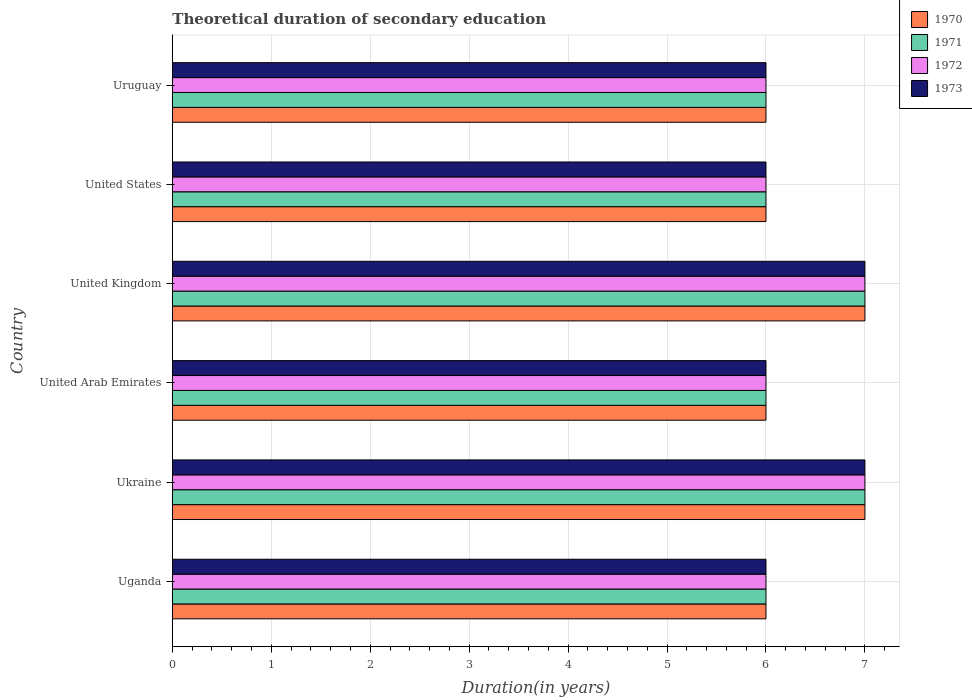Are the number of bars on each tick of the Y-axis equal?
Make the answer very short. Yes. How many bars are there on the 2nd tick from the top?
Ensure brevity in your answer.  4. What is the label of the 2nd group of bars from the top?
Provide a succinct answer. United States. Across all countries, what is the maximum total theoretical duration of secondary education in 1972?
Offer a terse response. 7. In which country was the total theoretical duration of secondary education in 1972 maximum?
Provide a succinct answer. Ukraine. In which country was the total theoretical duration of secondary education in 1973 minimum?
Your answer should be compact. Uganda. What is the total total theoretical duration of secondary education in 1972 in the graph?
Keep it short and to the point. 38. What is the average total theoretical duration of secondary education in 1973 per country?
Provide a short and direct response. 6.33. In how many countries, is the total theoretical duration of secondary education in 1971 greater than 5 years?
Give a very brief answer. 6. What is the difference between the highest and the lowest total theoretical duration of secondary education in 1972?
Your answer should be compact. 1. Is it the case that in every country, the sum of the total theoretical duration of secondary education in 1973 and total theoretical duration of secondary education in 1971 is greater than the sum of total theoretical duration of secondary education in 1970 and total theoretical duration of secondary education in 1972?
Offer a terse response. No. Is it the case that in every country, the sum of the total theoretical duration of secondary education in 1973 and total theoretical duration of secondary education in 1970 is greater than the total theoretical duration of secondary education in 1972?
Provide a succinct answer. Yes. How many bars are there?
Your answer should be compact. 24. How many countries are there in the graph?
Provide a short and direct response. 6. Are the values on the major ticks of X-axis written in scientific E-notation?
Provide a succinct answer. No. Does the graph contain any zero values?
Your response must be concise. No. Does the graph contain grids?
Give a very brief answer. Yes. How are the legend labels stacked?
Offer a terse response. Vertical. What is the title of the graph?
Offer a very short reply. Theoretical duration of secondary education. What is the label or title of the X-axis?
Provide a short and direct response. Duration(in years). What is the Duration(in years) in 1972 in Uganda?
Your answer should be compact. 6. What is the Duration(in years) in 1973 in Uganda?
Your response must be concise. 6. What is the Duration(in years) of 1970 in Ukraine?
Your answer should be compact. 7. What is the Duration(in years) of 1973 in Ukraine?
Give a very brief answer. 7. What is the Duration(in years) in 1970 in United Arab Emirates?
Your response must be concise. 6. What is the Duration(in years) of 1972 in United Arab Emirates?
Give a very brief answer. 6. What is the Duration(in years) of 1973 in United Arab Emirates?
Your answer should be very brief. 6. What is the Duration(in years) of 1970 in United Kingdom?
Provide a short and direct response. 7. What is the Duration(in years) in 1971 in United Kingdom?
Keep it short and to the point. 7. What is the Duration(in years) of 1972 in United Kingdom?
Ensure brevity in your answer.  7. What is the Duration(in years) of 1973 in United Kingdom?
Provide a succinct answer. 7. What is the Duration(in years) of 1972 in United States?
Give a very brief answer. 6. What is the Duration(in years) of 1973 in United States?
Your response must be concise. 6. What is the Duration(in years) in 1971 in Uruguay?
Give a very brief answer. 6. Across all countries, what is the minimum Duration(in years) of 1971?
Keep it short and to the point. 6. What is the total Duration(in years) of 1971 in the graph?
Give a very brief answer. 38. What is the total Duration(in years) in 1972 in the graph?
Your answer should be very brief. 38. What is the difference between the Duration(in years) in 1970 in Uganda and that in Ukraine?
Your answer should be very brief. -1. What is the difference between the Duration(in years) of 1971 in Uganda and that in Ukraine?
Offer a very short reply. -1. What is the difference between the Duration(in years) in 1973 in Uganda and that in Ukraine?
Your answer should be compact. -1. What is the difference between the Duration(in years) in 1970 in Uganda and that in United Arab Emirates?
Ensure brevity in your answer.  0. What is the difference between the Duration(in years) of 1971 in Uganda and that in United Arab Emirates?
Give a very brief answer. 0. What is the difference between the Duration(in years) of 1972 in Uganda and that in United Arab Emirates?
Provide a short and direct response. 0. What is the difference between the Duration(in years) of 1973 in Uganda and that in United Arab Emirates?
Keep it short and to the point. 0. What is the difference between the Duration(in years) in 1970 in Uganda and that in United Kingdom?
Ensure brevity in your answer.  -1. What is the difference between the Duration(in years) of 1971 in Uganda and that in United Kingdom?
Offer a very short reply. -1. What is the difference between the Duration(in years) in 1972 in Uganda and that in United Kingdom?
Keep it short and to the point. -1. What is the difference between the Duration(in years) of 1973 in Uganda and that in United Kingdom?
Provide a succinct answer. -1. What is the difference between the Duration(in years) of 1970 in Uganda and that in Uruguay?
Make the answer very short. 0. What is the difference between the Duration(in years) of 1972 in Ukraine and that in United Arab Emirates?
Give a very brief answer. 1. What is the difference between the Duration(in years) of 1973 in Ukraine and that in United Arab Emirates?
Give a very brief answer. 1. What is the difference between the Duration(in years) of 1971 in Ukraine and that in United Kingdom?
Make the answer very short. 0. What is the difference between the Duration(in years) in 1972 in Ukraine and that in United Kingdom?
Your answer should be very brief. 0. What is the difference between the Duration(in years) of 1973 in Ukraine and that in United Kingdom?
Make the answer very short. 0. What is the difference between the Duration(in years) of 1970 in Ukraine and that in Uruguay?
Keep it short and to the point. 1. What is the difference between the Duration(in years) in 1971 in Ukraine and that in Uruguay?
Ensure brevity in your answer.  1. What is the difference between the Duration(in years) of 1972 in Ukraine and that in Uruguay?
Your answer should be compact. 1. What is the difference between the Duration(in years) in 1973 in Ukraine and that in Uruguay?
Give a very brief answer. 1. What is the difference between the Duration(in years) of 1971 in United Arab Emirates and that in United Kingdom?
Your answer should be very brief. -1. What is the difference between the Duration(in years) of 1972 in United Arab Emirates and that in United Kingdom?
Ensure brevity in your answer.  -1. What is the difference between the Duration(in years) of 1970 in United Arab Emirates and that in United States?
Give a very brief answer. 0. What is the difference between the Duration(in years) in 1971 in United Arab Emirates and that in United States?
Provide a succinct answer. 0. What is the difference between the Duration(in years) of 1972 in United Arab Emirates and that in United States?
Offer a terse response. 0. What is the difference between the Duration(in years) in 1973 in United Arab Emirates and that in United States?
Ensure brevity in your answer.  0. What is the difference between the Duration(in years) in 1970 in United Arab Emirates and that in Uruguay?
Make the answer very short. 0. What is the difference between the Duration(in years) of 1971 in United Arab Emirates and that in Uruguay?
Offer a very short reply. 0. What is the difference between the Duration(in years) of 1973 in United Arab Emirates and that in Uruguay?
Offer a very short reply. 0. What is the difference between the Duration(in years) of 1971 in United Kingdom and that in United States?
Keep it short and to the point. 1. What is the difference between the Duration(in years) in 1971 in United Kingdom and that in Uruguay?
Your response must be concise. 1. What is the difference between the Duration(in years) of 1972 in United Kingdom and that in Uruguay?
Provide a short and direct response. 1. What is the difference between the Duration(in years) in 1971 in United States and that in Uruguay?
Make the answer very short. 0. What is the difference between the Duration(in years) in 1972 in United States and that in Uruguay?
Give a very brief answer. 0. What is the difference between the Duration(in years) in 1970 in Uganda and the Duration(in years) in 1971 in Ukraine?
Your response must be concise. -1. What is the difference between the Duration(in years) of 1971 in Uganda and the Duration(in years) of 1973 in Ukraine?
Ensure brevity in your answer.  -1. What is the difference between the Duration(in years) in 1970 in Uganda and the Duration(in years) in 1971 in United Arab Emirates?
Offer a very short reply. 0. What is the difference between the Duration(in years) in 1971 in Uganda and the Duration(in years) in 1972 in United Arab Emirates?
Make the answer very short. 0. What is the difference between the Duration(in years) of 1971 in Uganda and the Duration(in years) of 1973 in United Arab Emirates?
Your answer should be very brief. 0. What is the difference between the Duration(in years) of 1970 in Uganda and the Duration(in years) of 1972 in United Kingdom?
Provide a short and direct response. -1. What is the difference between the Duration(in years) in 1971 in Uganda and the Duration(in years) in 1973 in United Kingdom?
Offer a terse response. -1. What is the difference between the Duration(in years) of 1972 in Uganda and the Duration(in years) of 1973 in United Kingdom?
Offer a very short reply. -1. What is the difference between the Duration(in years) in 1970 in Uganda and the Duration(in years) in 1971 in United States?
Provide a short and direct response. 0. What is the difference between the Duration(in years) of 1970 in Uganda and the Duration(in years) of 1973 in United States?
Give a very brief answer. 0. What is the difference between the Duration(in years) of 1972 in Uganda and the Duration(in years) of 1973 in United States?
Keep it short and to the point. 0. What is the difference between the Duration(in years) of 1970 in Uganda and the Duration(in years) of 1973 in Uruguay?
Your answer should be very brief. 0. What is the difference between the Duration(in years) of 1971 in Uganda and the Duration(in years) of 1973 in Uruguay?
Give a very brief answer. 0. What is the difference between the Duration(in years) of 1972 in Uganda and the Duration(in years) of 1973 in Uruguay?
Offer a very short reply. 0. What is the difference between the Duration(in years) in 1972 in Ukraine and the Duration(in years) in 1973 in United Arab Emirates?
Keep it short and to the point. 1. What is the difference between the Duration(in years) in 1970 in Ukraine and the Duration(in years) in 1973 in United Kingdom?
Offer a very short reply. 0. What is the difference between the Duration(in years) in 1971 in Ukraine and the Duration(in years) in 1973 in United Kingdom?
Provide a short and direct response. 0. What is the difference between the Duration(in years) of 1971 in Ukraine and the Duration(in years) of 1972 in United States?
Your answer should be compact. 1. What is the difference between the Duration(in years) in 1970 in Ukraine and the Duration(in years) in 1971 in Uruguay?
Make the answer very short. 1. What is the difference between the Duration(in years) in 1970 in Ukraine and the Duration(in years) in 1972 in Uruguay?
Offer a terse response. 1. What is the difference between the Duration(in years) in 1970 in Ukraine and the Duration(in years) in 1973 in Uruguay?
Offer a terse response. 1. What is the difference between the Duration(in years) in 1971 in Ukraine and the Duration(in years) in 1973 in Uruguay?
Your answer should be compact. 1. What is the difference between the Duration(in years) of 1972 in Ukraine and the Duration(in years) of 1973 in Uruguay?
Offer a very short reply. 1. What is the difference between the Duration(in years) of 1971 in United Arab Emirates and the Duration(in years) of 1973 in United Kingdom?
Make the answer very short. -1. What is the difference between the Duration(in years) of 1972 in United Arab Emirates and the Duration(in years) of 1973 in United Kingdom?
Provide a succinct answer. -1. What is the difference between the Duration(in years) in 1970 in United Arab Emirates and the Duration(in years) in 1971 in United States?
Give a very brief answer. 0. What is the difference between the Duration(in years) in 1970 in United Arab Emirates and the Duration(in years) in 1972 in United States?
Keep it short and to the point. 0. What is the difference between the Duration(in years) in 1971 in United Arab Emirates and the Duration(in years) in 1973 in United States?
Provide a short and direct response. 0. What is the difference between the Duration(in years) in 1970 in United Arab Emirates and the Duration(in years) in 1971 in Uruguay?
Make the answer very short. 0. What is the difference between the Duration(in years) in 1970 in United Arab Emirates and the Duration(in years) in 1973 in Uruguay?
Your answer should be very brief. 0. What is the difference between the Duration(in years) of 1970 in United Kingdom and the Duration(in years) of 1971 in United States?
Your answer should be compact. 1. What is the difference between the Duration(in years) of 1970 in United Kingdom and the Duration(in years) of 1972 in United States?
Give a very brief answer. 1. What is the difference between the Duration(in years) of 1971 in United Kingdom and the Duration(in years) of 1972 in United States?
Provide a succinct answer. 1. What is the difference between the Duration(in years) of 1972 in United Kingdom and the Duration(in years) of 1973 in United States?
Make the answer very short. 1. What is the difference between the Duration(in years) in 1970 in United Kingdom and the Duration(in years) in 1972 in Uruguay?
Provide a short and direct response. 1. What is the difference between the Duration(in years) in 1970 in United Kingdom and the Duration(in years) in 1973 in Uruguay?
Make the answer very short. 1. What is the difference between the Duration(in years) of 1972 in United Kingdom and the Duration(in years) of 1973 in Uruguay?
Make the answer very short. 1. What is the difference between the Duration(in years) in 1970 in United States and the Duration(in years) in 1971 in Uruguay?
Your response must be concise. 0. What is the difference between the Duration(in years) in 1970 in United States and the Duration(in years) in 1972 in Uruguay?
Your answer should be compact. 0. What is the difference between the Duration(in years) of 1970 in United States and the Duration(in years) of 1973 in Uruguay?
Your response must be concise. 0. What is the average Duration(in years) of 1970 per country?
Your answer should be compact. 6.33. What is the average Duration(in years) in 1971 per country?
Ensure brevity in your answer.  6.33. What is the average Duration(in years) in 1972 per country?
Your answer should be compact. 6.33. What is the average Duration(in years) in 1973 per country?
Give a very brief answer. 6.33. What is the difference between the Duration(in years) in 1971 and Duration(in years) in 1973 in Uganda?
Provide a short and direct response. 0. What is the difference between the Duration(in years) in 1972 and Duration(in years) in 1973 in Uganda?
Make the answer very short. 0. What is the difference between the Duration(in years) in 1970 and Duration(in years) in 1971 in Ukraine?
Give a very brief answer. 0. What is the difference between the Duration(in years) in 1970 and Duration(in years) in 1972 in Ukraine?
Your response must be concise. 0. What is the difference between the Duration(in years) in 1970 and Duration(in years) in 1972 in United Arab Emirates?
Provide a short and direct response. 0. What is the difference between the Duration(in years) in 1970 and Duration(in years) in 1973 in United Arab Emirates?
Your answer should be compact. 0. What is the difference between the Duration(in years) in 1970 and Duration(in years) in 1971 in United Kingdom?
Give a very brief answer. 0. What is the difference between the Duration(in years) of 1970 and Duration(in years) of 1972 in United Kingdom?
Make the answer very short. 0. What is the difference between the Duration(in years) in 1970 and Duration(in years) in 1973 in United Kingdom?
Ensure brevity in your answer.  0. What is the difference between the Duration(in years) of 1971 and Duration(in years) of 1972 in United Kingdom?
Ensure brevity in your answer.  0. What is the difference between the Duration(in years) of 1971 and Duration(in years) of 1973 in United Kingdom?
Your answer should be compact. 0. What is the difference between the Duration(in years) of 1970 and Duration(in years) of 1971 in United States?
Offer a terse response. 0. What is the difference between the Duration(in years) in 1970 and Duration(in years) in 1972 in United States?
Give a very brief answer. 0. What is the difference between the Duration(in years) of 1970 and Duration(in years) of 1973 in United States?
Offer a very short reply. 0. What is the difference between the Duration(in years) in 1971 and Duration(in years) in 1972 in United States?
Provide a short and direct response. 0. What is the difference between the Duration(in years) in 1972 and Duration(in years) in 1973 in United States?
Offer a terse response. 0. What is the difference between the Duration(in years) in 1970 and Duration(in years) in 1973 in Uruguay?
Your answer should be compact. 0. What is the difference between the Duration(in years) of 1971 and Duration(in years) of 1972 in Uruguay?
Offer a terse response. 0. What is the difference between the Duration(in years) in 1972 and Duration(in years) in 1973 in Uruguay?
Your answer should be very brief. 0. What is the ratio of the Duration(in years) of 1970 in Uganda to that in Ukraine?
Provide a succinct answer. 0.86. What is the ratio of the Duration(in years) of 1971 in Uganda to that in Ukraine?
Ensure brevity in your answer.  0.86. What is the ratio of the Duration(in years) of 1970 in Uganda to that in United Arab Emirates?
Provide a short and direct response. 1. What is the ratio of the Duration(in years) in 1973 in Uganda to that in United Arab Emirates?
Your answer should be very brief. 1. What is the ratio of the Duration(in years) in 1970 in Uganda to that in United Kingdom?
Offer a very short reply. 0.86. What is the ratio of the Duration(in years) in 1971 in Uganda to that in United Kingdom?
Your answer should be compact. 0.86. What is the ratio of the Duration(in years) of 1972 in Uganda to that in United Kingdom?
Your response must be concise. 0.86. What is the ratio of the Duration(in years) in 1970 in Uganda to that in United States?
Offer a terse response. 1. What is the ratio of the Duration(in years) in 1971 in Uganda to that in United States?
Your answer should be compact. 1. What is the ratio of the Duration(in years) of 1972 in Uganda to that in United States?
Provide a short and direct response. 1. What is the ratio of the Duration(in years) in 1973 in Uganda to that in United States?
Ensure brevity in your answer.  1. What is the ratio of the Duration(in years) of 1971 in Uganda to that in Uruguay?
Your response must be concise. 1. What is the ratio of the Duration(in years) in 1973 in Uganda to that in Uruguay?
Your response must be concise. 1. What is the ratio of the Duration(in years) of 1970 in Ukraine to that in United Arab Emirates?
Provide a succinct answer. 1.17. What is the ratio of the Duration(in years) of 1971 in Ukraine to that in United Arab Emirates?
Your answer should be very brief. 1.17. What is the ratio of the Duration(in years) of 1972 in Ukraine to that in United Arab Emirates?
Provide a succinct answer. 1.17. What is the ratio of the Duration(in years) of 1973 in Ukraine to that in United Arab Emirates?
Ensure brevity in your answer.  1.17. What is the ratio of the Duration(in years) of 1971 in Ukraine to that in United Kingdom?
Provide a succinct answer. 1. What is the ratio of the Duration(in years) of 1973 in Ukraine to that in United Kingdom?
Provide a succinct answer. 1. What is the ratio of the Duration(in years) in 1970 in Ukraine to that in United States?
Your response must be concise. 1.17. What is the ratio of the Duration(in years) of 1973 in Ukraine to that in United States?
Ensure brevity in your answer.  1.17. What is the ratio of the Duration(in years) in 1971 in Ukraine to that in Uruguay?
Make the answer very short. 1.17. What is the ratio of the Duration(in years) in 1973 in Ukraine to that in Uruguay?
Keep it short and to the point. 1.17. What is the ratio of the Duration(in years) of 1970 in United Arab Emirates to that in United Kingdom?
Offer a terse response. 0.86. What is the ratio of the Duration(in years) of 1970 in United Arab Emirates to that in United States?
Offer a very short reply. 1. What is the ratio of the Duration(in years) in 1972 in United Arab Emirates to that in Uruguay?
Give a very brief answer. 1. What is the ratio of the Duration(in years) in 1973 in United Arab Emirates to that in Uruguay?
Your answer should be very brief. 1. What is the ratio of the Duration(in years) of 1972 in United Kingdom to that in United States?
Give a very brief answer. 1.17. What is the ratio of the Duration(in years) of 1973 in United Kingdom to that in United States?
Provide a succinct answer. 1.17. What is the ratio of the Duration(in years) of 1970 in United Kingdom to that in Uruguay?
Offer a very short reply. 1.17. What is the ratio of the Duration(in years) in 1971 in United Kingdom to that in Uruguay?
Provide a succinct answer. 1.17. What is the ratio of the Duration(in years) of 1972 in United Kingdom to that in Uruguay?
Offer a very short reply. 1.17. What is the ratio of the Duration(in years) in 1970 in United States to that in Uruguay?
Make the answer very short. 1. What is the ratio of the Duration(in years) of 1971 in United States to that in Uruguay?
Your answer should be very brief. 1. What is the difference between the highest and the second highest Duration(in years) of 1970?
Provide a succinct answer. 0. What is the difference between the highest and the second highest Duration(in years) of 1973?
Your answer should be very brief. 0. What is the difference between the highest and the lowest Duration(in years) of 1971?
Provide a succinct answer. 1. What is the difference between the highest and the lowest Duration(in years) of 1972?
Give a very brief answer. 1. 